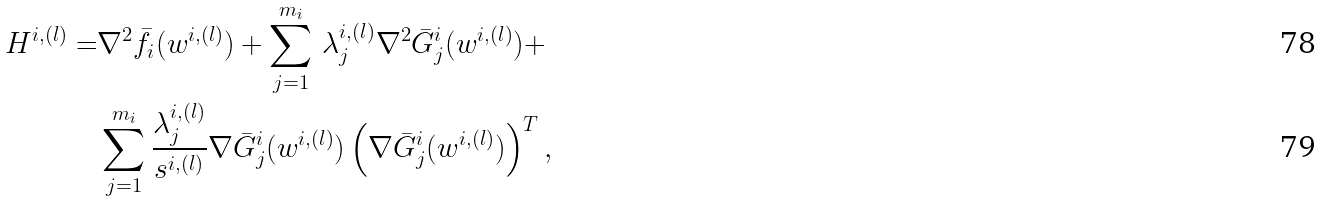Convert formula to latex. <formula><loc_0><loc_0><loc_500><loc_500>H ^ { i , ( l ) } = & \nabla ^ { 2 } \bar { f } _ { i } ( w ^ { i , ( l ) } ) + \sum _ { j = 1 } ^ { m _ { i } } \, \lambda ^ { i , ( l ) } _ { j } \nabla ^ { 2 } \bar { G } _ { j } ^ { i } ( w ^ { i , ( l ) } ) + \\ & \sum _ { j = 1 } ^ { m _ { i } } \frac { \lambda ^ { i , ( l ) } _ { j } } { s ^ { i , ( l ) } } \nabla \bar { G } _ { j } ^ { i } ( w ^ { i , ( l ) } ) \left ( \nabla \bar { G } _ { j } ^ { i } ( w ^ { i , ( l ) } ) \right ) ^ { T } ,</formula> 